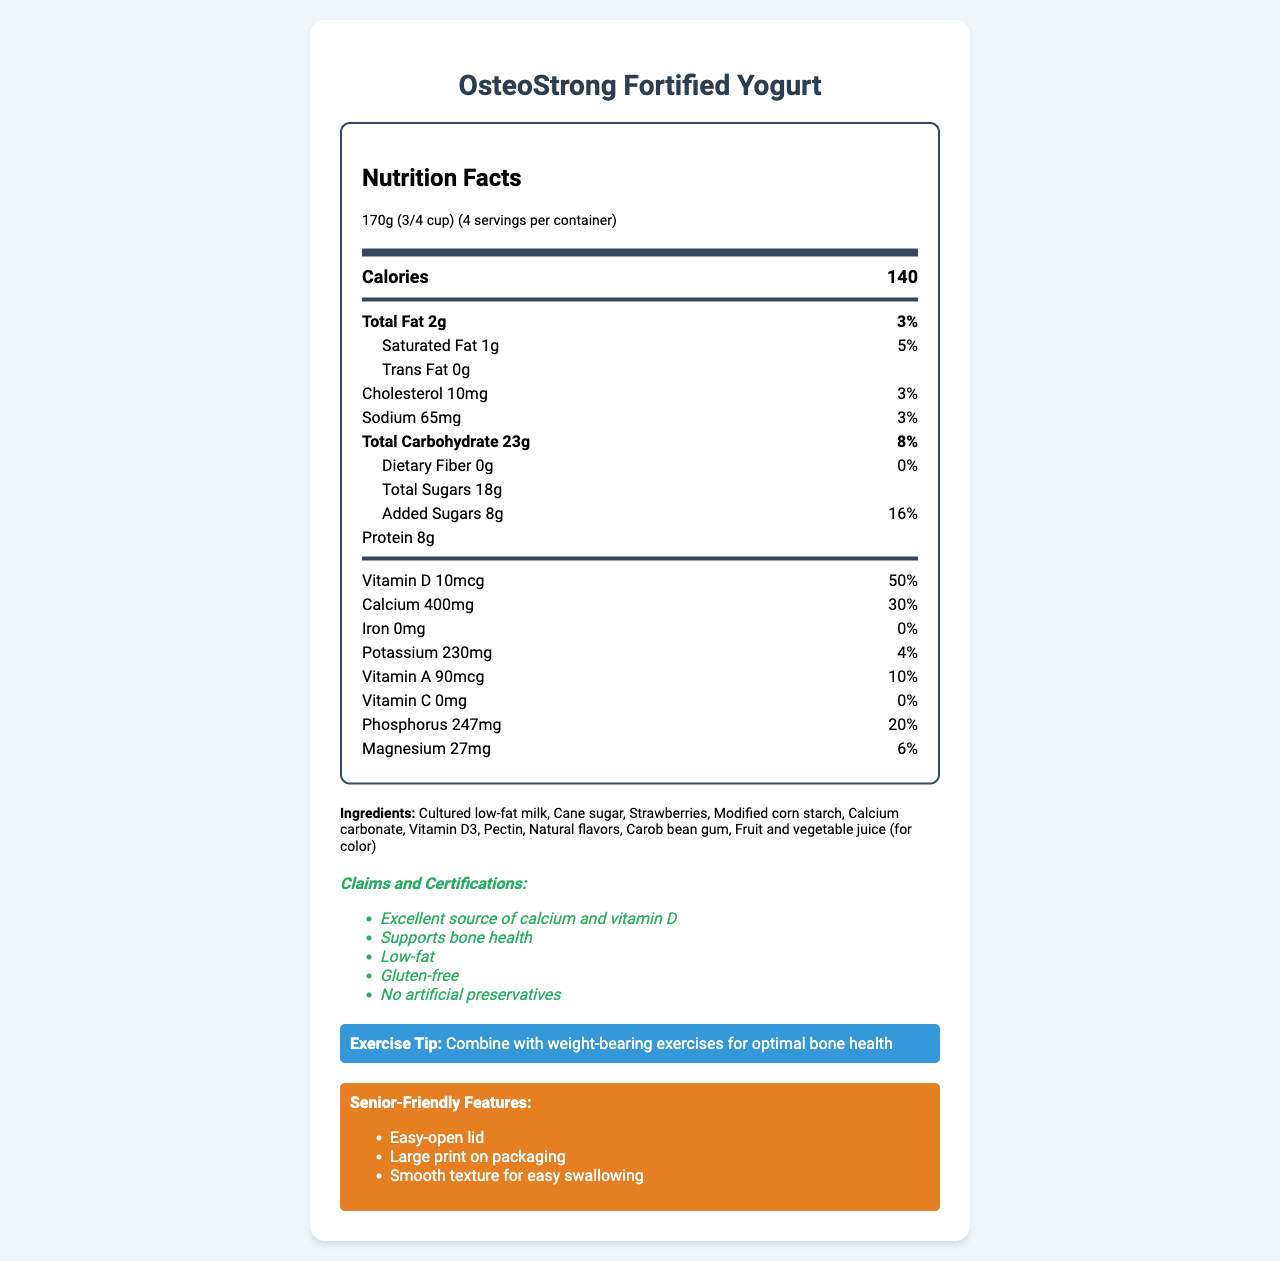what is the serving size of OsteoStrong Fortified Yogurt? The serving size is listed at the top of the nutrition label, indicated as 170g (3/4 cup).
Answer: 170g (3/4 cup) how many calories are in one serving? The document states that there are 140 calories per serving of the yogurt.
Answer: 140 how much calcium does one serving provide? One serving of the yogurt provides 400mg of calcium, which is 30% of the daily value.
Answer: 400mg what percentage of the daily value for vitamin D does the product provide? The document lists that one serving offers 50% of the daily value for vitamin D.
Answer: 50% what is the amount of added sugars in one serving of this product? The amount of added sugars is mentioned as 8g per serving.
Answer: 8g is this product gluten-free? The claims and certifications section specifies that the product is gluten-free.
Answer: Yes which nutrient is present in the highest percentage of daily value? a. Vitamin D b. Calcium c. Phosphorus d. Potassium Vitamin D provides 50% of the daily value, which is the highest among the listed nutrients.
Answer: a. Vitamin D which of these features make the product senior-friendly? a. Large print on packaging b. Smooth texture for easy swallowing c. Easy-open lid d. All of the above The senior-friendly features include large print on packaging, smooth texture for easy swallowing, and an easy-open lid.
Answer: d. All of the above is there any iron in this product? The document mentions that the amount of iron is 0mg, which means there is no iron in the product.
Answer: No does this product contain artificial preservatives? The document clarifies that the product contains no artificial preservatives in the claims and certifications section.
Answer: No summarize the main features of OsteoStrong Fortified Yogurt related to bone health. The document presents OsteoStrong Fortified Yogurt as a nutritious dairy product enhanced with calcium and vitamin D to support bone health. It also highlights the product’s low-fat content, gluten-free status, and claims of containing no artificial preservatives. The product’s senior-friendly features are also summarized.
Answer: OsteoStrong Fortified Yogurt is a low-fat, gluten-free product rich in calcium and vitamin D, supporting bone health. It contains no artificial preservatives and includes senior-friendly features like an easy-open lid, large print on packaging, and a smooth texture. who is the manufacturer of the product? The manufacturer information at the end of the document lists HealthyBones Dairy Co. as the maker of the product.
Answer: HealthyBones Dairy Co. how much sodium does one serving contain? The nutrition facts indicate that one serving contains 65mg of sodium, which is 3% of the daily value.
Answer: 65mg how many servings does the container have? The document states that the yogurt container includes 4 servings.
Answer: 4 what is the street address of the manufacturer? The document provides the address of the manufacturer as 123 Wellness Ave, Fitville, CA 90210.
Answer: 123 Wellness Ave, Fitville, CA 90210 what is the price of the product? The document does not provide any information regarding the price of the product.
Answer: Cannot be determined 